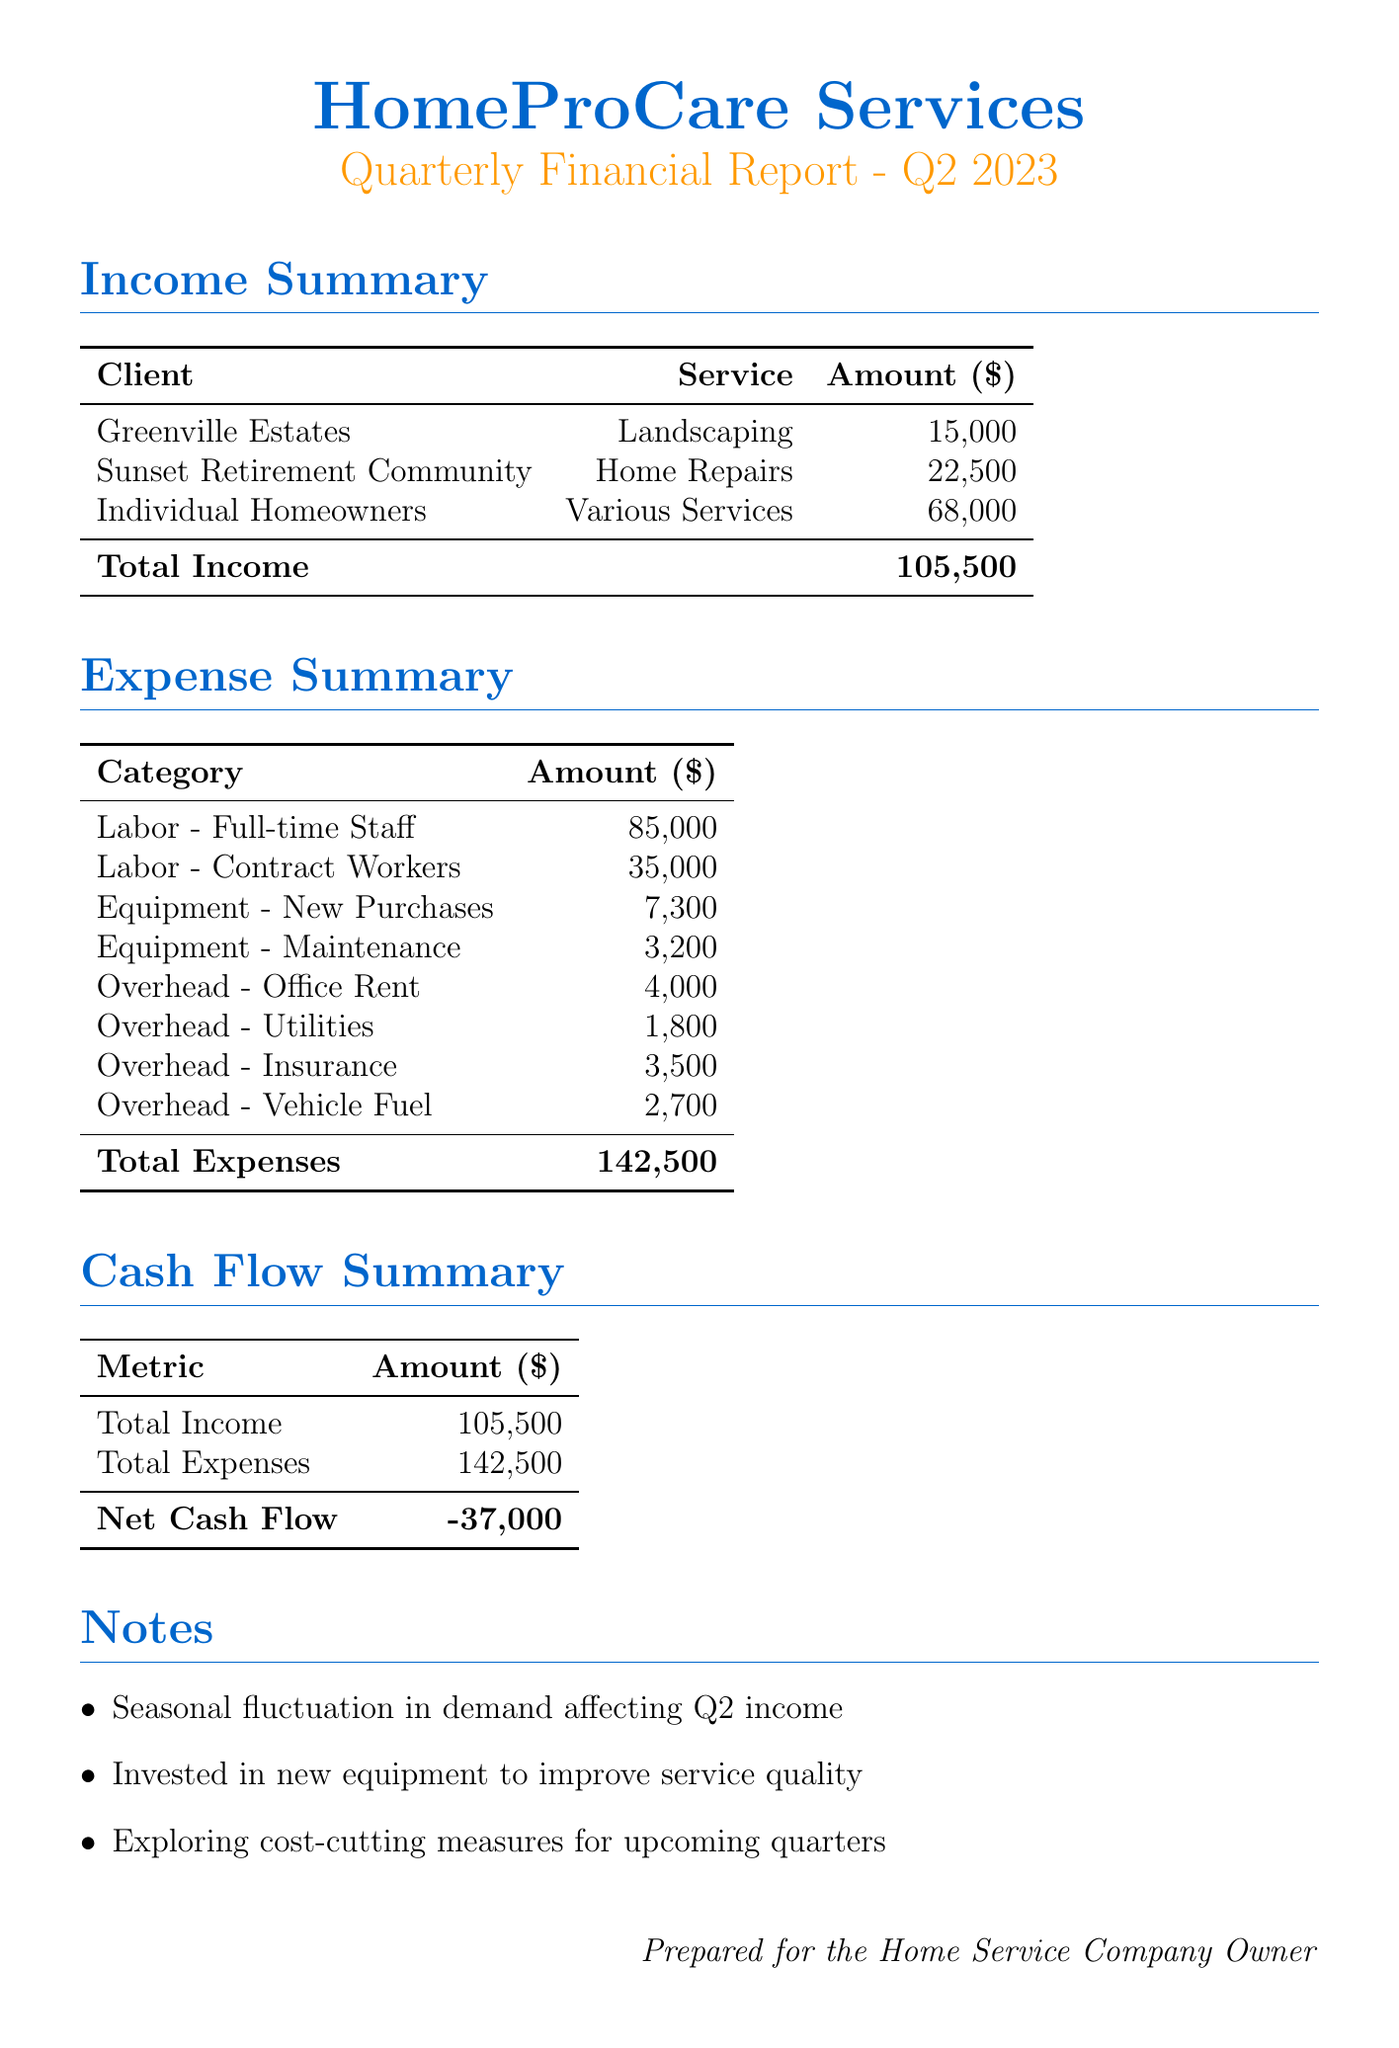what is the total income for Q2 2023? The total income is provided in the cash flow summary and is the sum of all incoming payments, which totals to $105,500.
Answer: $105,500 what is the amount received from Individual Homeowners? This information is listed under the income summary section, specifically indicating that the amount received from Individual Homeowners is $68,000.
Answer: $68,000 what are the new equipment purchases listed? The document specifies two new equipment purchases: LawnMaster 3000 for $4,500 and PowerTools Set for $2,800, both of which are categorized under new purchases.
Answer: LawnMaster 3000, PowerTools Set what is the total for labor expenses? The labor expenses consist of full-time staff and contract workers, which total to $85,000 and $35,000, respectively, adding up to $120,000 in total.
Answer: $120,000 what is the net cash flow for Q2 2023? The net cash flow can be found in the cash flow summary section, which shows a negative cash flow of $37,000, equal to total income minus total expenses.
Answer: -$37,000 what is the largest outgoing expense category? Analyzing the outgoing expenses, labor expenses amounting to $120,000 is the largest category when combined, exceeding other categories listed in the document.
Answer: Labor what are the overhead costs mentioned? The overhead costs listed in the document include office rent, utilities, insurance, and vehicle fuel, with specific amounts for each expense provided.
Answer: Office Rent, Utilities, Insurance, Vehicle Fuel what seasonal factor affected Q2 income? A note within the report highlights a seasonal fluctuation in demand, which has affected the income for the second quarter.
Answer: Seasonal fluctuation what is the amount spent on equipment maintenance? Equipment maintenance expenses are explicitly stated in the document as $3,200, derived from the equipment section.
Answer: $3,200 